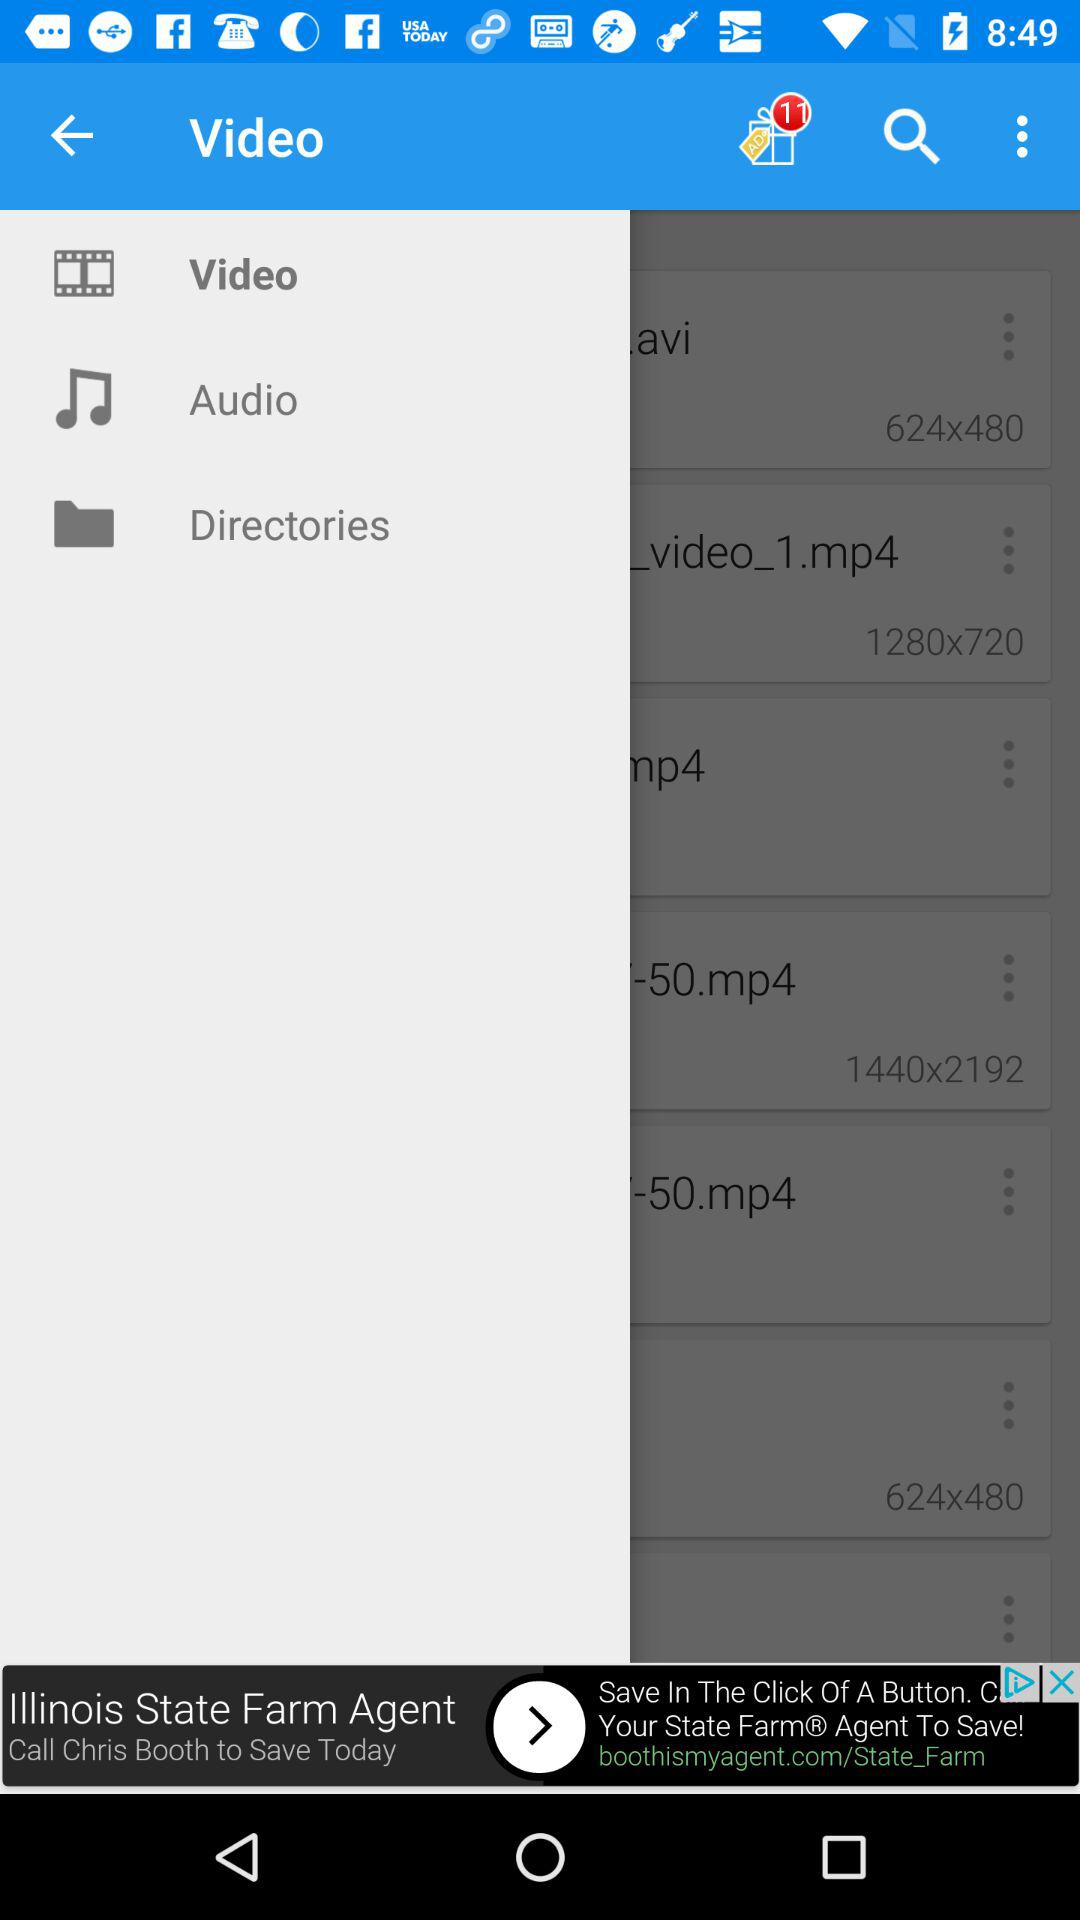How many notifications are pending? There are 11 pending notifications. 